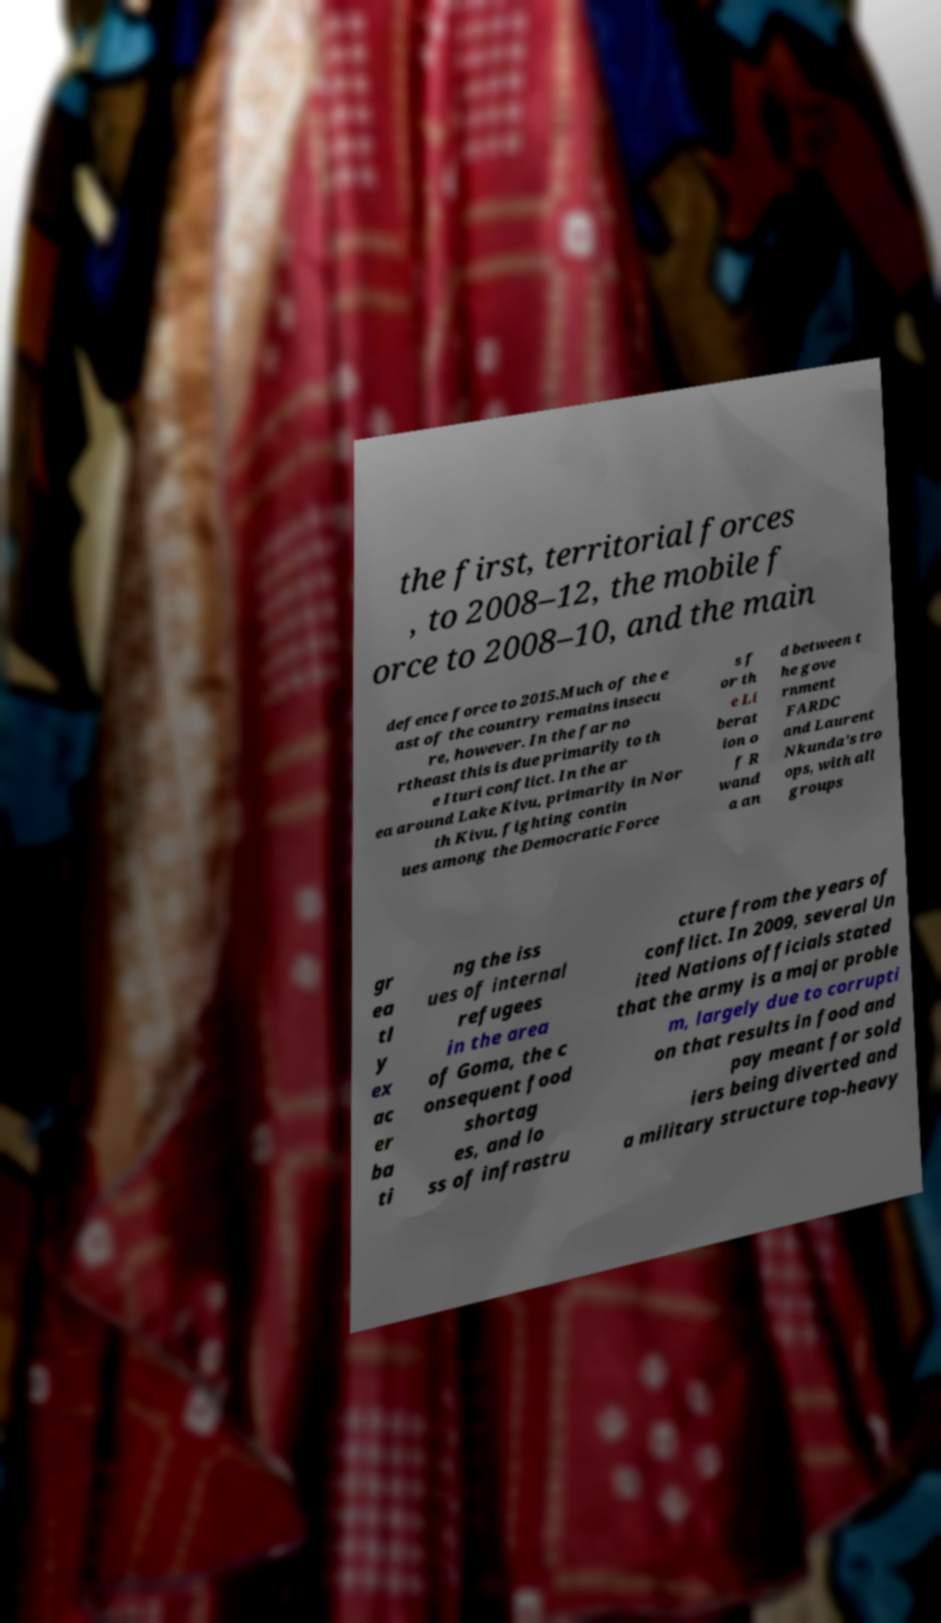Please identify and transcribe the text found in this image. the first, territorial forces , to 2008–12, the mobile f orce to 2008–10, and the main defence force to 2015.Much of the e ast of the country remains insecu re, however. In the far no rtheast this is due primarily to th e Ituri conflict. In the ar ea around Lake Kivu, primarily in Nor th Kivu, fighting contin ues among the Democratic Force s f or th e Li berat ion o f R wand a an d between t he gove rnment FARDC and Laurent Nkunda's tro ops, with all groups gr ea tl y ex ac er ba ti ng the iss ues of internal refugees in the area of Goma, the c onsequent food shortag es, and lo ss of infrastru cture from the years of conflict. In 2009, several Un ited Nations officials stated that the army is a major proble m, largely due to corrupti on that results in food and pay meant for sold iers being diverted and a military structure top-heavy 